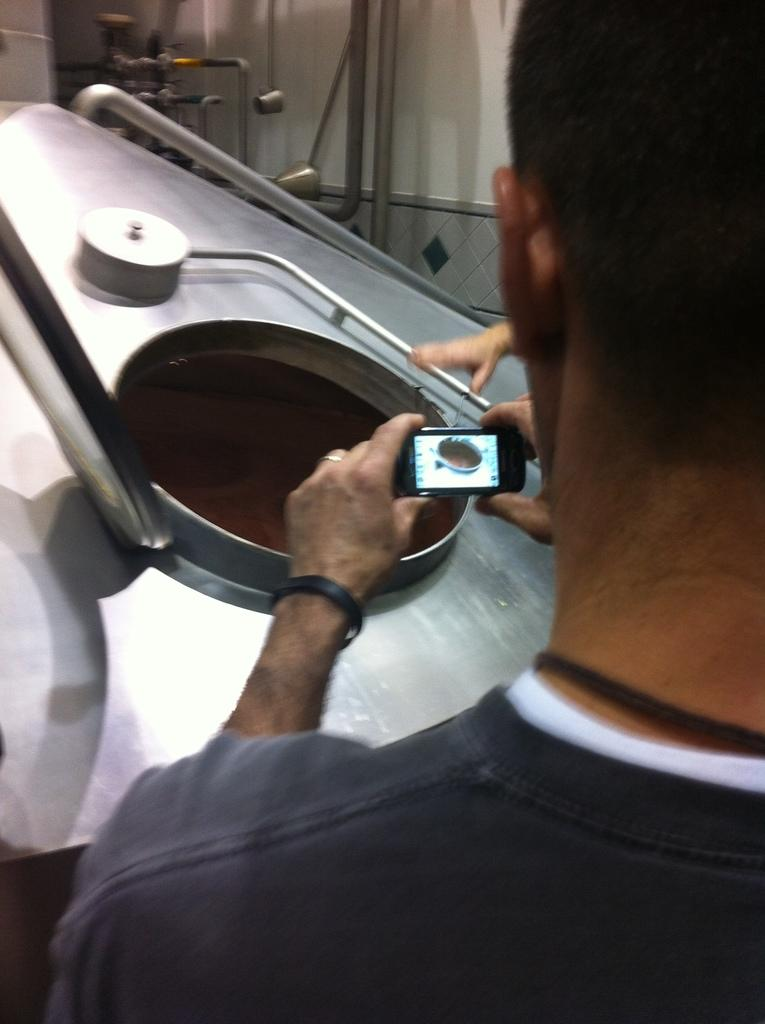Who is present in the image? There is a man in the image. What is the man holding in the image? The man is holding a mobile phone. What structure can be seen in the image? There is a dome in the image. Reasoning: Let's think step by step by step in order to produce the conversation. We start by identifying the main subject in the image, which is the man. Then, we expand the conversation to include what the man is holding, which is a mobile phone. Finally, we mention the structure present in the image, which is a dome. Each question is designed to elicit a specific detail about the image that is known from the provided facts. Absurd Question/Answer: How many balloons are tied to the swing in the image? There are no balloons or swings present in the image. 